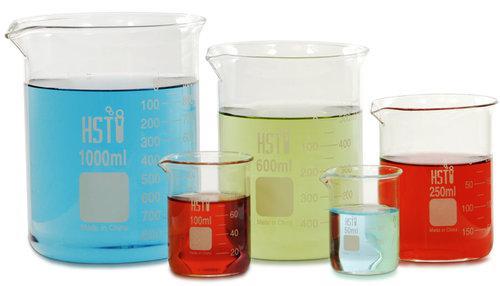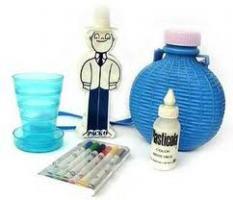The first image is the image on the left, the second image is the image on the right. For the images shown, is this caption "At least one of the containers in one of the images is empty." true? Answer yes or no. Yes. The first image is the image on the left, the second image is the image on the right. For the images displayed, is the sentence "The containers in the left image are empty." factually correct? Answer yes or no. No. 